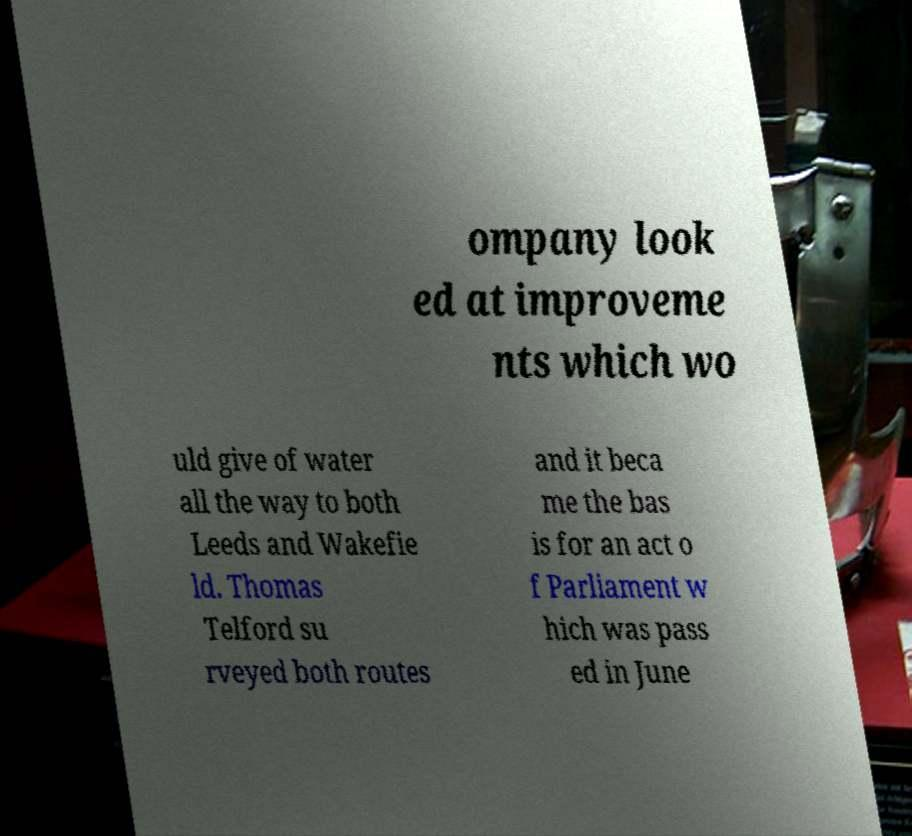Please read and relay the text visible in this image. What does it say? ompany look ed at improveme nts which wo uld give of water all the way to both Leeds and Wakefie ld. Thomas Telford su rveyed both routes and it beca me the bas is for an act o f Parliament w hich was pass ed in June 